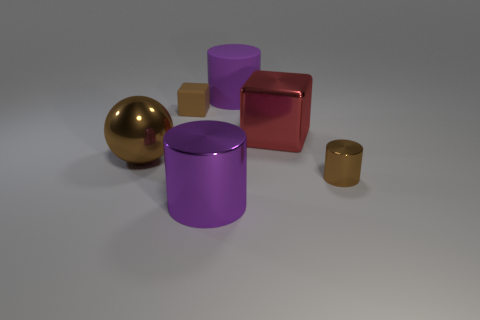There is a large metallic object in front of the big shiny object left of the rubber cube; how many cylinders are to the right of it?
Provide a short and direct response. 2. What material is the tiny brown thing behind the cube to the right of the thing behind the small cube?
Provide a short and direct response. Rubber. Is the material of the small object in front of the tiny matte cube the same as the ball?
Offer a very short reply. Yes. What number of red things have the same size as the metal ball?
Make the answer very short. 1. Is the number of rubber objects that are left of the tiny brown shiny cylinder greater than the number of tiny rubber cubes behind the tiny brown block?
Give a very brief answer. Yes. Is there a big cyan metallic object of the same shape as the tiny rubber thing?
Offer a very short reply. No. There is a shiny object left of the block that is on the left side of the purple shiny cylinder; how big is it?
Make the answer very short. Large. There is a brown shiny object that is to the right of the big purple object left of the cylinder behind the large brown metallic thing; what shape is it?
Ensure brevity in your answer.  Cylinder. What size is the cylinder that is made of the same material as the tiny brown block?
Offer a terse response. Large. Are there more big metal balls than large green matte cubes?
Your answer should be compact. Yes. 